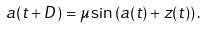Convert formula to latex. <formula><loc_0><loc_0><loc_500><loc_500>a ( t + D ) = \mu \sin \left ( a ( t ) + z ( t ) \right ) .</formula> 